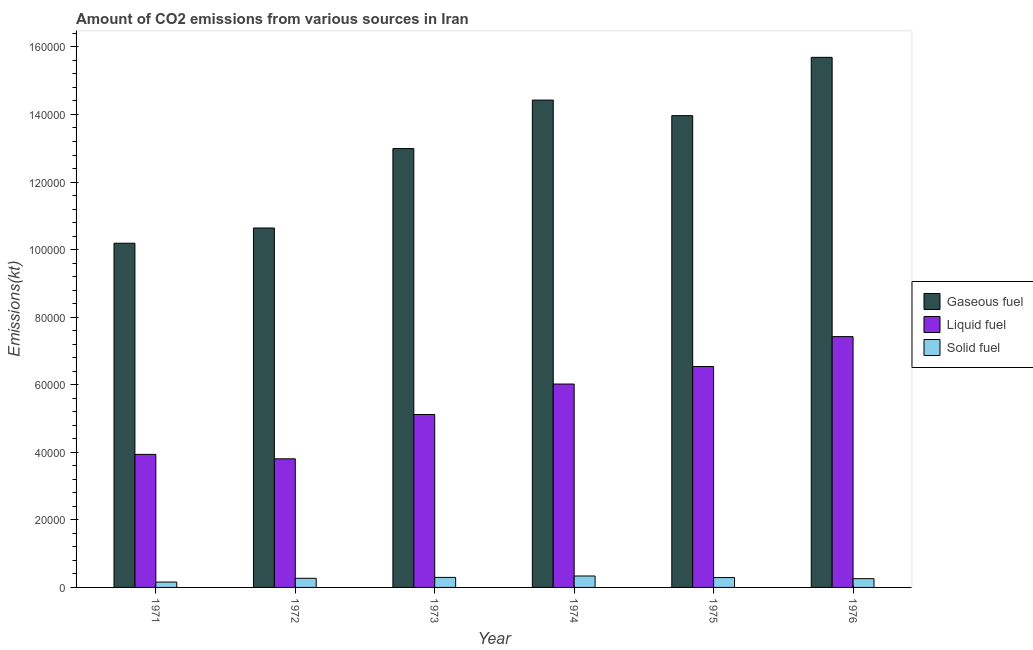How many different coloured bars are there?
Offer a very short reply. 3. What is the label of the 5th group of bars from the left?
Your answer should be very brief. 1975. What is the amount of co2 emissions from gaseous fuel in 1972?
Offer a terse response. 1.06e+05. Across all years, what is the maximum amount of co2 emissions from gaseous fuel?
Your response must be concise. 1.57e+05. Across all years, what is the minimum amount of co2 emissions from liquid fuel?
Ensure brevity in your answer.  3.81e+04. In which year was the amount of co2 emissions from liquid fuel maximum?
Provide a short and direct response. 1976. What is the total amount of co2 emissions from liquid fuel in the graph?
Provide a succinct answer. 3.28e+05. What is the difference between the amount of co2 emissions from solid fuel in 1971 and that in 1972?
Offer a terse response. -1111.1. What is the difference between the amount of co2 emissions from solid fuel in 1973 and the amount of co2 emissions from gaseous fuel in 1972?
Ensure brevity in your answer.  267.69. What is the average amount of co2 emissions from solid fuel per year?
Offer a terse response. 2692.8. What is the ratio of the amount of co2 emissions from liquid fuel in 1971 to that in 1972?
Make the answer very short. 1.03. Is the amount of co2 emissions from gaseous fuel in 1971 less than that in 1973?
Ensure brevity in your answer.  Yes. Is the difference between the amount of co2 emissions from solid fuel in 1975 and 1976 greater than the difference between the amount of co2 emissions from gaseous fuel in 1975 and 1976?
Ensure brevity in your answer.  No. What is the difference between the highest and the second highest amount of co2 emissions from gaseous fuel?
Offer a terse response. 1.27e+04. What is the difference between the highest and the lowest amount of co2 emissions from solid fuel?
Your answer should be very brief. 1793.16. In how many years, is the amount of co2 emissions from gaseous fuel greater than the average amount of co2 emissions from gaseous fuel taken over all years?
Give a very brief answer. 4. What does the 2nd bar from the left in 1974 represents?
Your response must be concise. Liquid fuel. What does the 3rd bar from the right in 1974 represents?
Offer a terse response. Gaseous fuel. How many bars are there?
Make the answer very short. 18. How many years are there in the graph?
Keep it short and to the point. 6. Does the graph contain any zero values?
Offer a very short reply. No. Where does the legend appear in the graph?
Provide a succinct answer. Center right. How many legend labels are there?
Offer a very short reply. 3. What is the title of the graph?
Keep it short and to the point. Amount of CO2 emissions from various sources in Iran. Does "Self-employed" appear as one of the legend labels in the graph?
Give a very brief answer. No. What is the label or title of the Y-axis?
Provide a succinct answer. Emissions(kt). What is the Emissions(kt) in Gaseous fuel in 1971?
Ensure brevity in your answer.  1.02e+05. What is the Emissions(kt) of Liquid fuel in 1971?
Ensure brevity in your answer.  3.94e+04. What is the Emissions(kt) of Solid fuel in 1971?
Provide a succinct answer. 1591.48. What is the Emissions(kt) of Gaseous fuel in 1972?
Your response must be concise. 1.06e+05. What is the Emissions(kt) in Liquid fuel in 1972?
Ensure brevity in your answer.  3.81e+04. What is the Emissions(kt) in Solid fuel in 1972?
Give a very brief answer. 2702.58. What is the Emissions(kt) in Gaseous fuel in 1973?
Your response must be concise. 1.30e+05. What is the Emissions(kt) in Liquid fuel in 1973?
Your answer should be very brief. 5.12e+04. What is the Emissions(kt) of Solid fuel in 1973?
Make the answer very short. 2970.27. What is the Emissions(kt) of Gaseous fuel in 1974?
Make the answer very short. 1.44e+05. What is the Emissions(kt) in Liquid fuel in 1974?
Provide a succinct answer. 6.02e+04. What is the Emissions(kt) in Solid fuel in 1974?
Your answer should be very brief. 3384.64. What is the Emissions(kt) of Gaseous fuel in 1975?
Make the answer very short. 1.40e+05. What is the Emissions(kt) in Liquid fuel in 1975?
Provide a succinct answer. 6.54e+04. What is the Emissions(kt) in Solid fuel in 1975?
Your response must be concise. 2915.26. What is the Emissions(kt) of Gaseous fuel in 1976?
Your answer should be very brief. 1.57e+05. What is the Emissions(kt) in Liquid fuel in 1976?
Provide a short and direct response. 7.42e+04. What is the Emissions(kt) in Solid fuel in 1976?
Your answer should be very brief. 2592.57. Across all years, what is the maximum Emissions(kt) of Gaseous fuel?
Your answer should be compact. 1.57e+05. Across all years, what is the maximum Emissions(kt) of Liquid fuel?
Your answer should be compact. 7.42e+04. Across all years, what is the maximum Emissions(kt) in Solid fuel?
Ensure brevity in your answer.  3384.64. Across all years, what is the minimum Emissions(kt) in Gaseous fuel?
Provide a short and direct response. 1.02e+05. Across all years, what is the minimum Emissions(kt) in Liquid fuel?
Keep it short and to the point. 3.81e+04. Across all years, what is the minimum Emissions(kt) of Solid fuel?
Provide a short and direct response. 1591.48. What is the total Emissions(kt) of Gaseous fuel in the graph?
Keep it short and to the point. 7.79e+05. What is the total Emissions(kt) of Liquid fuel in the graph?
Ensure brevity in your answer.  3.28e+05. What is the total Emissions(kt) of Solid fuel in the graph?
Keep it short and to the point. 1.62e+04. What is the difference between the Emissions(kt) in Gaseous fuel in 1971 and that in 1972?
Provide a succinct answer. -4510.41. What is the difference between the Emissions(kt) in Liquid fuel in 1971 and that in 1972?
Ensure brevity in your answer.  1320.12. What is the difference between the Emissions(kt) of Solid fuel in 1971 and that in 1972?
Your answer should be very brief. -1111.1. What is the difference between the Emissions(kt) of Gaseous fuel in 1971 and that in 1973?
Ensure brevity in your answer.  -2.80e+04. What is the difference between the Emissions(kt) of Liquid fuel in 1971 and that in 1973?
Offer a very short reply. -1.18e+04. What is the difference between the Emissions(kt) in Solid fuel in 1971 and that in 1973?
Provide a short and direct response. -1378.79. What is the difference between the Emissions(kt) of Gaseous fuel in 1971 and that in 1974?
Give a very brief answer. -4.24e+04. What is the difference between the Emissions(kt) of Liquid fuel in 1971 and that in 1974?
Give a very brief answer. -2.08e+04. What is the difference between the Emissions(kt) in Solid fuel in 1971 and that in 1974?
Keep it short and to the point. -1793.16. What is the difference between the Emissions(kt) in Gaseous fuel in 1971 and that in 1975?
Your response must be concise. -3.78e+04. What is the difference between the Emissions(kt) in Liquid fuel in 1971 and that in 1975?
Your response must be concise. -2.60e+04. What is the difference between the Emissions(kt) in Solid fuel in 1971 and that in 1975?
Your response must be concise. -1323.79. What is the difference between the Emissions(kt) in Gaseous fuel in 1971 and that in 1976?
Offer a very short reply. -5.50e+04. What is the difference between the Emissions(kt) in Liquid fuel in 1971 and that in 1976?
Offer a terse response. -3.49e+04. What is the difference between the Emissions(kt) in Solid fuel in 1971 and that in 1976?
Your answer should be very brief. -1001.09. What is the difference between the Emissions(kt) in Gaseous fuel in 1972 and that in 1973?
Offer a terse response. -2.35e+04. What is the difference between the Emissions(kt) of Liquid fuel in 1972 and that in 1973?
Make the answer very short. -1.31e+04. What is the difference between the Emissions(kt) in Solid fuel in 1972 and that in 1973?
Ensure brevity in your answer.  -267.69. What is the difference between the Emissions(kt) in Gaseous fuel in 1972 and that in 1974?
Provide a succinct answer. -3.79e+04. What is the difference between the Emissions(kt) of Liquid fuel in 1972 and that in 1974?
Keep it short and to the point. -2.21e+04. What is the difference between the Emissions(kt) in Solid fuel in 1972 and that in 1974?
Your answer should be compact. -682.06. What is the difference between the Emissions(kt) in Gaseous fuel in 1972 and that in 1975?
Provide a short and direct response. -3.33e+04. What is the difference between the Emissions(kt) in Liquid fuel in 1972 and that in 1975?
Provide a short and direct response. -2.73e+04. What is the difference between the Emissions(kt) in Solid fuel in 1972 and that in 1975?
Make the answer very short. -212.69. What is the difference between the Emissions(kt) of Gaseous fuel in 1972 and that in 1976?
Make the answer very short. -5.05e+04. What is the difference between the Emissions(kt) of Liquid fuel in 1972 and that in 1976?
Give a very brief answer. -3.62e+04. What is the difference between the Emissions(kt) of Solid fuel in 1972 and that in 1976?
Give a very brief answer. 110.01. What is the difference between the Emissions(kt) in Gaseous fuel in 1973 and that in 1974?
Keep it short and to the point. -1.44e+04. What is the difference between the Emissions(kt) in Liquid fuel in 1973 and that in 1974?
Keep it short and to the point. -9024.49. What is the difference between the Emissions(kt) of Solid fuel in 1973 and that in 1974?
Your response must be concise. -414.37. What is the difference between the Emissions(kt) in Gaseous fuel in 1973 and that in 1975?
Provide a short and direct response. -9746.89. What is the difference between the Emissions(kt) of Liquid fuel in 1973 and that in 1975?
Ensure brevity in your answer.  -1.42e+04. What is the difference between the Emissions(kt) in Solid fuel in 1973 and that in 1975?
Give a very brief answer. 55.01. What is the difference between the Emissions(kt) of Gaseous fuel in 1973 and that in 1976?
Keep it short and to the point. -2.70e+04. What is the difference between the Emissions(kt) of Liquid fuel in 1973 and that in 1976?
Give a very brief answer. -2.31e+04. What is the difference between the Emissions(kt) of Solid fuel in 1973 and that in 1976?
Offer a very short reply. 377.7. What is the difference between the Emissions(kt) of Gaseous fuel in 1974 and that in 1975?
Provide a short and direct response. 4609.42. What is the difference between the Emissions(kt) in Liquid fuel in 1974 and that in 1975?
Offer a terse response. -5177.8. What is the difference between the Emissions(kt) of Solid fuel in 1974 and that in 1975?
Your answer should be compact. 469.38. What is the difference between the Emissions(kt) of Gaseous fuel in 1974 and that in 1976?
Your answer should be compact. -1.27e+04. What is the difference between the Emissions(kt) of Liquid fuel in 1974 and that in 1976?
Provide a succinct answer. -1.40e+04. What is the difference between the Emissions(kt) of Solid fuel in 1974 and that in 1976?
Your answer should be very brief. 792.07. What is the difference between the Emissions(kt) in Gaseous fuel in 1975 and that in 1976?
Your response must be concise. -1.73e+04. What is the difference between the Emissions(kt) of Liquid fuel in 1975 and that in 1976?
Provide a succinct answer. -8859.47. What is the difference between the Emissions(kt) of Solid fuel in 1975 and that in 1976?
Keep it short and to the point. 322.7. What is the difference between the Emissions(kt) in Gaseous fuel in 1971 and the Emissions(kt) in Liquid fuel in 1972?
Provide a short and direct response. 6.38e+04. What is the difference between the Emissions(kt) of Gaseous fuel in 1971 and the Emissions(kt) of Solid fuel in 1972?
Your response must be concise. 9.92e+04. What is the difference between the Emissions(kt) of Liquid fuel in 1971 and the Emissions(kt) of Solid fuel in 1972?
Make the answer very short. 3.67e+04. What is the difference between the Emissions(kt) in Gaseous fuel in 1971 and the Emissions(kt) in Liquid fuel in 1973?
Offer a very short reply. 5.07e+04. What is the difference between the Emissions(kt) of Gaseous fuel in 1971 and the Emissions(kt) of Solid fuel in 1973?
Offer a terse response. 9.89e+04. What is the difference between the Emissions(kt) in Liquid fuel in 1971 and the Emissions(kt) in Solid fuel in 1973?
Make the answer very short. 3.64e+04. What is the difference between the Emissions(kt) of Gaseous fuel in 1971 and the Emissions(kt) of Liquid fuel in 1974?
Give a very brief answer. 4.17e+04. What is the difference between the Emissions(kt) in Gaseous fuel in 1971 and the Emissions(kt) in Solid fuel in 1974?
Offer a terse response. 9.85e+04. What is the difference between the Emissions(kt) in Liquid fuel in 1971 and the Emissions(kt) in Solid fuel in 1974?
Provide a short and direct response. 3.60e+04. What is the difference between the Emissions(kt) in Gaseous fuel in 1971 and the Emissions(kt) in Liquid fuel in 1975?
Offer a terse response. 3.65e+04. What is the difference between the Emissions(kt) in Gaseous fuel in 1971 and the Emissions(kt) in Solid fuel in 1975?
Keep it short and to the point. 9.90e+04. What is the difference between the Emissions(kt) in Liquid fuel in 1971 and the Emissions(kt) in Solid fuel in 1975?
Give a very brief answer. 3.65e+04. What is the difference between the Emissions(kt) in Gaseous fuel in 1971 and the Emissions(kt) in Liquid fuel in 1976?
Keep it short and to the point. 2.76e+04. What is the difference between the Emissions(kt) in Gaseous fuel in 1971 and the Emissions(kt) in Solid fuel in 1976?
Keep it short and to the point. 9.93e+04. What is the difference between the Emissions(kt) in Liquid fuel in 1971 and the Emissions(kt) in Solid fuel in 1976?
Provide a succinct answer. 3.68e+04. What is the difference between the Emissions(kt) of Gaseous fuel in 1972 and the Emissions(kt) of Liquid fuel in 1973?
Your answer should be compact. 5.52e+04. What is the difference between the Emissions(kt) in Gaseous fuel in 1972 and the Emissions(kt) in Solid fuel in 1973?
Your answer should be very brief. 1.03e+05. What is the difference between the Emissions(kt) of Liquid fuel in 1972 and the Emissions(kt) of Solid fuel in 1973?
Ensure brevity in your answer.  3.51e+04. What is the difference between the Emissions(kt) of Gaseous fuel in 1972 and the Emissions(kt) of Liquid fuel in 1974?
Your response must be concise. 4.62e+04. What is the difference between the Emissions(kt) in Gaseous fuel in 1972 and the Emissions(kt) in Solid fuel in 1974?
Your answer should be compact. 1.03e+05. What is the difference between the Emissions(kt) of Liquid fuel in 1972 and the Emissions(kt) of Solid fuel in 1974?
Your answer should be compact. 3.47e+04. What is the difference between the Emissions(kt) of Gaseous fuel in 1972 and the Emissions(kt) of Liquid fuel in 1975?
Make the answer very short. 4.10e+04. What is the difference between the Emissions(kt) in Gaseous fuel in 1972 and the Emissions(kt) in Solid fuel in 1975?
Offer a very short reply. 1.03e+05. What is the difference between the Emissions(kt) in Liquid fuel in 1972 and the Emissions(kt) in Solid fuel in 1975?
Make the answer very short. 3.52e+04. What is the difference between the Emissions(kt) in Gaseous fuel in 1972 and the Emissions(kt) in Liquid fuel in 1976?
Offer a terse response. 3.22e+04. What is the difference between the Emissions(kt) in Gaseous fuel in 1972 and the Emissions(kt) in Solid fuel in 1976?
Your answer should be very brief. 1.04e+05. What is the difference between the Emissions(kt) of Liquid fuel in 1972 and the Emissions(kt) of Solid fuel in 1976?
Your answer should be compact. 3.55e+04. What is the difference between the Emissions(kt) of Gaseous fuel in 1973 and the Emissions(kt) of Liquid fuel in 1974?
Make the answer very short. 6.97e+04. What is the difference between the Emissions(kt) in Gaseous fuel in 1973 and the Emissions(kt) in Solid fuel in 1974?
Your answer should be very brief. 1.27e+05. What is the difference between the Emissions(kt) in Liquid fuel in 1973 and the Emissions(kt) in Solid fuel in 1974?
Offer a very short reply. 4.78e+04. What is the difference between the Emissions(kt) of Gaseous fuel in 1973 and the Emissions(kt) of Liquid fuel in 1975?
Your response must be concise. 6.45e+04. What is the difference between the Emissions(kt) in Gaseous fuel in 1973 and the Emissions(kt) in Solid fuel in 1975?
Your answer should be compact. 1.27e+05. What is the difference between the Emissions(kt) of Liquid fuel in 1973 and the Emissions(kt) of Solid fuel in 1975?
Keep it short and to the point. 4.83e+04. What is the difference between the Emissions(kt) of Gaseous fuel in 1973 and the Emissions(kt) of Liquid fuel in 1976?
Your response must be concise. 5.57e+04. What is the difference between the Emissions(kt) of Gaseous fuel in 1973 and the Emissions(kt) of Solid fuel in 1976?
Offer a terse response. 1.27e+05. What is the difference between the Emissions(kt) of Liquid fuel in 1973 and the Emissions(kt) of Solid fuel in 1976?
Keep it short and to the point. 4.86e+04. What is the difference between the Emissions(kt) of Gaseous fuel in 1974 and the Emissions(kt) of Liquid fuel in 1975?
Offer a very short reply. 7.89e+04. What is the difference between the Emissions(kt) of Gaseous fuel in 1974 and the Emissions(kt) of Solid fuel in 1975?
Provide a short and direct response. 1.41e+05. What is the difference between the Emissions(kt) of Liquid fuel in 1974 and the Emissions(kt) of Solid fuel in 1975?
Offer a very short reply. 5.73e+04. What is the difference between the Emissions(kt) in Gaseous fuel in 1974 and the Emissions(kt) in Liquid fuel in 1976?
Give a very brief answer. 7.00e+04. What is the difference between the Emissions(kt) in Gaseous fuel in 1974 and the Emissions(kt) in Solid fuel in 1976?
Provide a short and direct response. 1.42e+05. What is the difference between the Emissions(kt) of Liquid fuel in 1974 and the Emissions(kt) of Solid fuel in 1976?
Provide a succinct answer. 5.76e+04. What is the difference between the Emissions(kt) of Gaseous fuel in 1975 and the Emissions(kt) of Liquid fuel in 1976?
Give a very brief answer. 6.54e+04. What is the difference between the Emissions(kt) of Gaseous fuel in 1975 and the Emissions(kt) of Solid fuel in 1976?
Keep it short and to the point. 1.37e+05. What is the difference between the Emissions(kt) in Liquid fuel in 1975 and the Emissions(kt) in Solid fuel in 1976?
Provide a succinct answer. 6.28e+04. What is the average Emissions(kt) in Gaseous fuel per year?
Keep it short and to the point. 1.30e+05. What is the average Emissions(kt) of Liquid fuel per year?
Provide a short and direct response. 5.47e+04. What is the average Emissions(kt) of Solid fuel per year?
Your response must be concise. 2692.8. In the year 1971, what is the difference between the Emissions(kt) in Gaseous fuel and Emissions(kt) in Liquid fuel?
Your answer should be very brief. 6.25e+04. In the year 1971, what is the difference between the Emissions(kt) of Gaseous fuel and Emissions(kt) of Solid fuel?
Your response must be concise. 1.00e+05. In the year 1971, what is the difference between the Emissions(kt) of Liquid fuel and Emissions(kt) of Solid fuel?
Your answer should be compact. 3.78e+04. In the year 1972, what is the difference between the Emissions(kt) in Gaseous fuel and Emissions(kt) in Liquid fuel?
Give a very brief answer. 6.83e+04. In the year 1972, what is the difference between the Emissions(kt) of Gaseous fuel and Emissions(kt) of Solid fuel?
Provide a short and direct response. 1.04e+05. In the year 1972, what is the difference between the Emissions(kt) in Liquid fuel and Emissions(kt) in Solid fuel?
Ensure brevity in your answer.  3.54e+04. In the year 1973, what is the difference between the Emissions(kt) in Gaseous fuel and Emissions(kt) in Liquid fuel?
Keep it short and to the point. 7.87e+04. In the year 1973, what is the difference between the Emissions(kt) of Gaseous fuel and Emissions(kt) of Solid fuel?
Keep it short and to the point. 1.27e+05. In the year 1973, what is the difference between the Emissions(kt) of Liquid fuel and Emissions(kt) of Solid fuel?
Provide a short and direct response. 4.82e+04. In the year 1974, what is the difference between the Emissions(kt) of Gaseous fuel and Emissions(kt) of Liquid fuel?
Offer a terse response. 8.41e+04. In the year 1974, what is the difference between the Emissions(kt) in Gaseous fuel and Emissions(kt) in Solid fuel?
Give a very brief answer. 1.41e+05. In the year 1974, what is the difference between the Emissions(kt) of Liquid fuel and Emissions(kt) of Solid fuel?
Your answer should be very brief. 5.68e+04. In the year 1975, what is the difference between the Emissions(kt) of Gaseous fuel and Emissions(kt) of Liquid fuel?
Provide a short and direct response. 7.43e+04. In the year 1975, what is the difference between the Emissions(kt) of Gaseous fuel and Emissions(kt) of Solid fuel?
Keep it short and to the point. 1.37e+05. In the year 1975, what is the difference between the Emissions(kt) in Liquid fuel and Emissions(kt) in Solid fuel?
Provide a short and direct response. 6.25e+04. In the year 1976, what is the difference between the Emissions(kt) of Gaseous fuel and Emissions(kt) of Liquid fuel?
Offer a terse response. 8.27e+04. In the year 1976, what is the difference between the Emissions(kt) of Gaseous fuel and Emissions(kt) of Solid fuel?
Ensure brevity in your answer.  1.54e+05. In the year 1976, what is the difference between the Emissions(kt) in Liquid fuel and Emissions(kt) in Solid fuel?
Ensure brevity in your answer.  7.16e+04. What is the ratio of the Emissions(kt) in Gaseous fuel in 1971 to that in 1972?
Make the answer very short. 0.96. What is the ratio of the Emissions(kt) of Liquid fuel in 1971 to that in 1972?
Offer a very short reply. 1.03. What is the ratio of the Emissions(kt) of Solid fuel in 1971 to that in 1972?
Provide a short and direct response. 0.59. What is the ratio of the Emissions(kt) in Gaseous fuel in 1971 to that in 1973?
Provide a short and direct response. 0.78. What is the ratio of the Emissions(kt) in Liquid fuel in 1971 to that in 1973?
Your answer should be compact. 0.77. What is the ratio of the Emissions(kt) in Solid fuel in 1971 to that in 1973?
Make the answer very short. 0.54. What is the ratio of the Emissions(kt) of Gaseous fuel in 1971 to that in 1974?
Offer a very short reply. 0.71. What is the ratio of the Emissions(kt) of Liquid fuel in 1971 to that in 1974?
Offer a very short reply. 0.65. What is the ratio of the Emissions(kt) in Solid fuel in 1971 to that in 1974?
Offer a terse response. 0.47. What is the ratio of the Emissions(kt) of Gaseous fuel in 1971 to that in 1975?
Ensure brevity in your answer.  0.73. What is the ratio of the Emissions(kt) of Liquid fuel in 1971 to that in 1975?
Make the answer very short. 0.6. What is the ratio of the Emissions(kt) of Solid fuel in 1971 to that in 1975?
Give a very brief answer. 0.55. What is the ratio of the Emissions(kt) in Gaseous fuel in 1971 to that in 1976?
Your answer should be compact. 0.65. What is the ratio of the Emissions(kt) of Liquid fuel in 1971 to that in 1976?
Make the answer very short. 0.53. What is the ratio of the Emissions(kt) in Solid fuel in 1971 to that in 1976?
Your answer should be compact. 0.61. What is the ratio of the Emissions(kt) of Gaseous fuel in 1972 to that in 1973?
Offer a terse response. 0.82. What is the ratio of the Emissions(kt) in Liquid fuel in 1972 to that in 1973?
Provide a short and direct response. 0.74. What is the ratio of the Emissions(kt) of Solid fuel in 1972 to that in 1973?
Your answer should be very brief. 0.91. What is the ratio of the Emissions(kt) of Gaseous fuel in 1972 to that in 1974?
Offer a terse response. 0.74. What is the ratio of the Emissions(kt) in Liquid fuel in 1972 to that in 1974?
Ensure brevity in your answer.  0.63. What is the ratio of the Emissions(kt) of Solid fuel in 1972 to that in 1974?
Your answer should be very brief. 0.8. What is the ratio of the Emissions(kt) of Gaseous fuel in 1972 to that in 1975?
Your answer should be compact. 0.76. What is the ratio of the Emissions(kt) of Liquid fuel in 1972 to that in 1975?
Your answer should be very brief. 0.58. What is the ratio of the Emissions(kt) in Solid fuel in 1972 to that in 1975?
Give a very brief answer. 0.93. What is the ratio of the Emissions(kt) of Gaseous fuel in 1972 to that in 1976?
Ensure brevity in your answer.  0.68. What is the ratio of the Emissions(kt) of Liquid fuel in 1972 to that in 1976?
Ensure brevity in your answer.  0.51. What is the ratio of the Emissions(kt) in Solid fuel in 1972 to that in 1976?
Your answer should be very brief. 1.04. What is the ratio of the Emissions(kt) of Gaseous fuel in 1973 to that in 1974?
Your answer should be very brief. 0.9. What is the ratio of the Emissions(kt) of Liquid fuel in 1973 to that in 1974?
Offer a terse response. 0.85. What is the ratio of the Emissions(kt) of Solid fuel in 1973 to that in 1974?
Offer a terse response. 0.88. What is the ratio of the Emissions(kt) in Gaseous fuel in 1973 to that in 1975?
Provide a short and direct response. 0.93. What is the ratio of the Emissions(kt) of Liquid fuel in 1973 to that in 1975?
Provide a short and direct response. 0.78. What is the ratio of the Emissions(kt) of Solid fuel in 1973 to that in 1975?
Keep it short and to the point. 1.02. What is the ratio of the Emissions(kt) of Gaseous fuel in 1973 to that in 1976?
Offer a very short reply. 0.83. What is the ratio of the Emissions(kt) of Liquid fuel in 1973 to that in 1976?
Offer a very short reply. 0.69. What is the ratio of the Emissions(kt) in Solid fuel in 1973 to that in 1976?
Offer a terse response. 1.15. What is the ratio of the Emissions(kt) in Gaseous fuel in 1974 to that in 1975?
Your response must be concise. 1.03. What is the ratio of the Emissions(kt) in Liquid fuel in 1974 to that in 1975?
Keep it short and to the point. 0.92. What is the ratio of the Emissions(kt) in Solid fuel in 1974 to that in 1975?
Offer a terse response. 1.16. What is the ratio of the Emissions(kt) of Gaseous fuel in 1974 to that in 1976?
Offer a very short reply. 0.92. What is the ratio of the Emissions(kt) in Liquid fuel in 1974 to that in 1976?
Give a very brief answer. 0.81. What is the ratio of the Emissions(kt) in Solid fuel in 1974 to that in 1976?
Provide a succinct answer. 1.31. What is the ratio of the Emissions(kt) of Gaseous fuel in 1975 to that in 1976?
Give a very brief answer. 0.89. What is the ratio of the Emissions(kt) of Liquid fuel in 1975 to that in 1976?
Provide a short and direct response. 0.88. What is the ratio of the Emissions(kt) in Solid fuel in 1975 to that in 1976?
Your answer should be compact. 1.12. What is the difference between the highest and the second highest Emissions(kt) in Gaseous fuel?
Make the answer very short. 1.27e+04. What is the difference between the highest and the second highest Emissions(kt) of Liquid fuel?
Your answer should be very brief. 8859.47. What is the difference between the highest and the second highest Emissions(kt) of Solid fuel?
Make the answer very short. 414.37. What is the difference between the highest and the lowest Emissions(kt) of Gaseous fuel?
Your answer should be compact. 5.50e+04. What is the difference between the highest and the lowest Emissions(kt) of Liquid fuel?
Offer a very short reply. 3.62e+04. What is the difference between the highest and the lowest Emissions(kt) in Solid fuel?
Your answer should be very brief. 1793.16. 